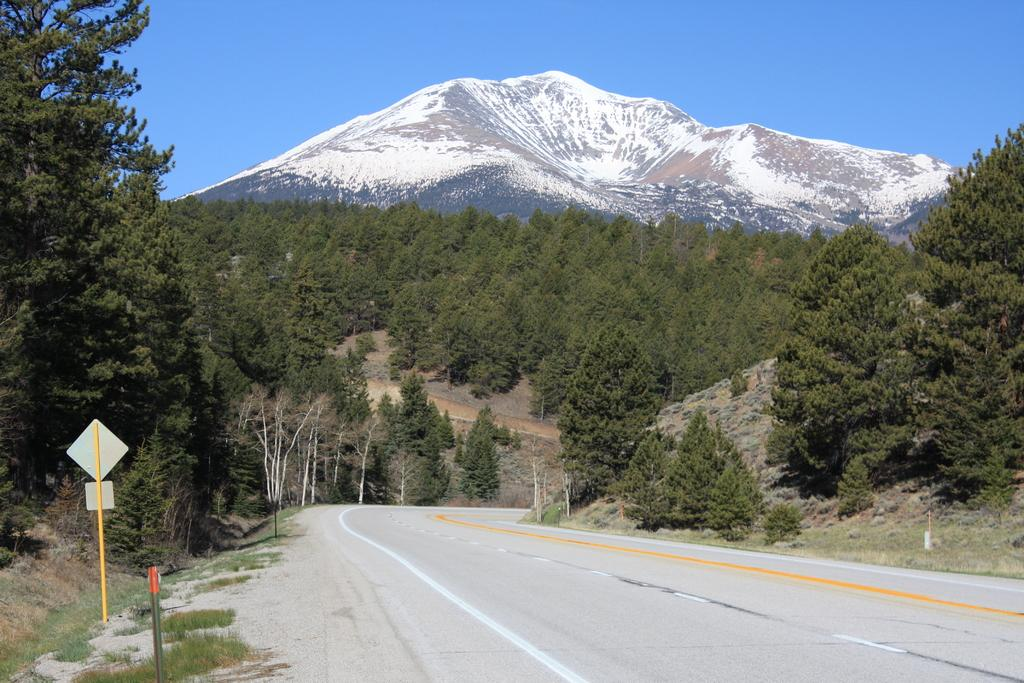What type of vegetation can be seen in the image? There is grass and plants visible in the image. What structures are present in the image? There are poles and boards visible in the image. What type of pathway is in the image? There is a road in the image. What type of natural features can be seen in the image? There are trees and a mountain visible in the image. What part of the natural environment is visible in the background of the image? The sky is visible in the background of the image. How does the mountain start to burst in the image? There is no indication in the image that the mountain is bursting or starting to burst. 